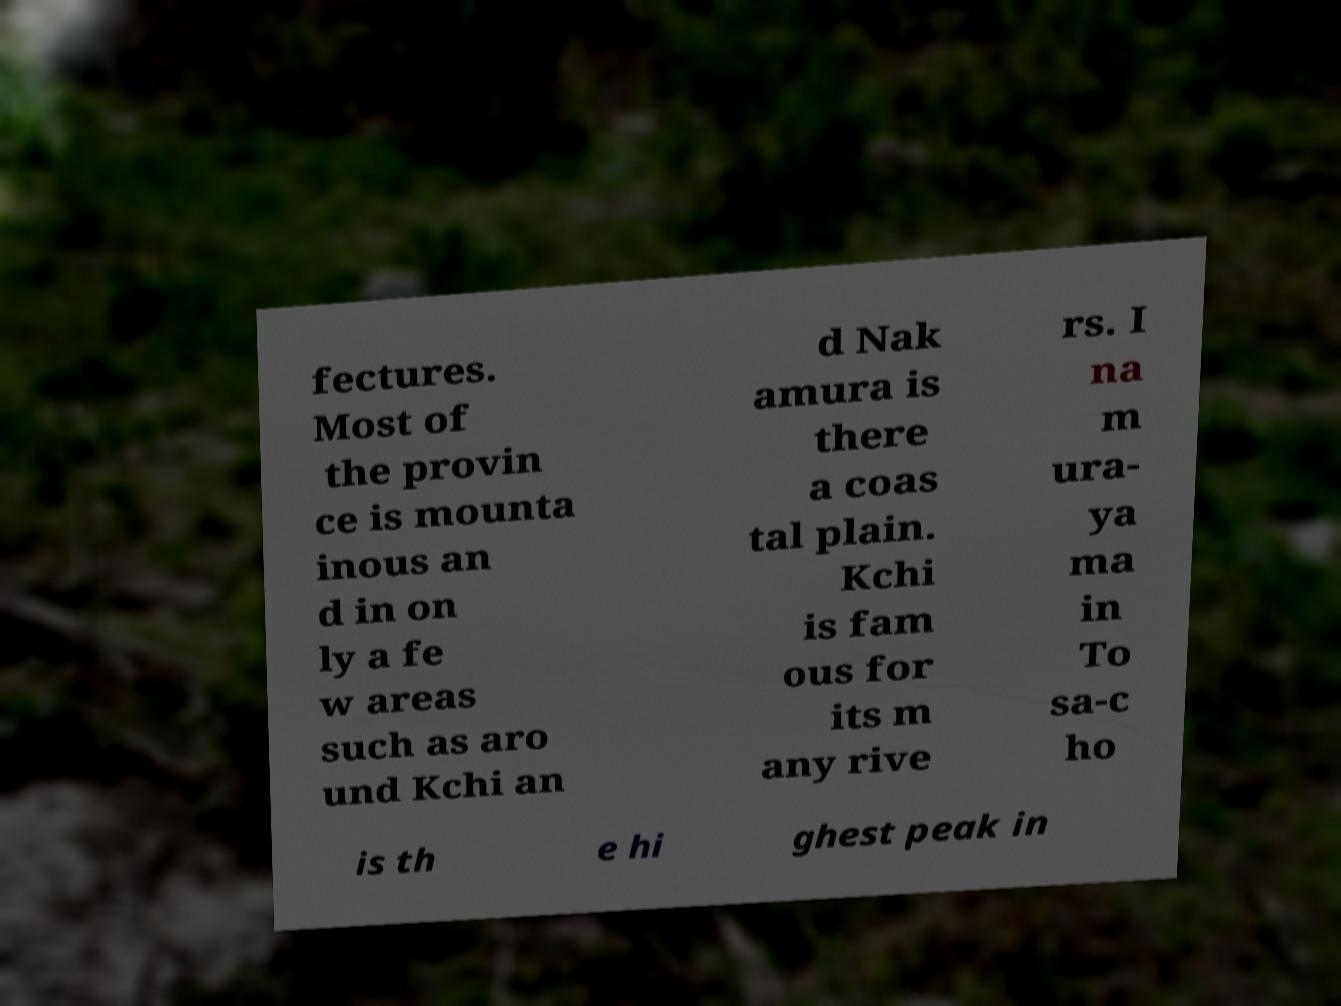For documentation purposes, I need the text within this image transcribed. Could you provide that? fectures. Most of the provin ce is mounta inous an d in on ly a fe w areas such as aro und Kchi an d Nak amura is there a coas tal plain. Kchi is fam ous for its m any rive rs. I na m ura- ya ma in To sa-c ho is th e hi ghest peak in 